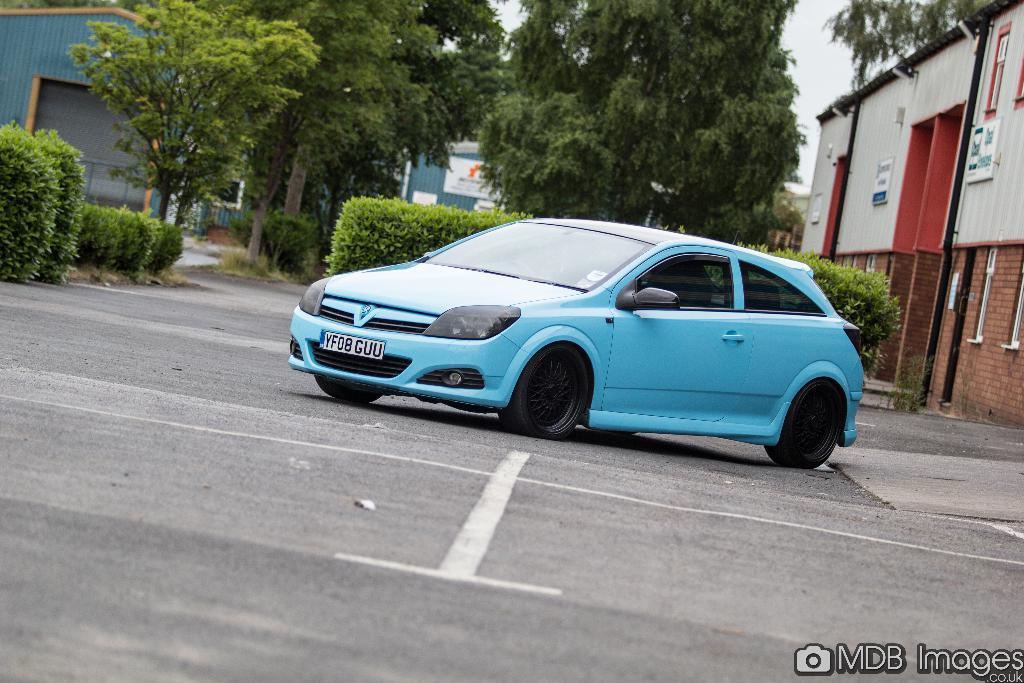Please provide a concise description of this image. In this image, we can see some trees, plants and sheds. There is a car in the middle of the image. There is a text in the bottom right of the image. 